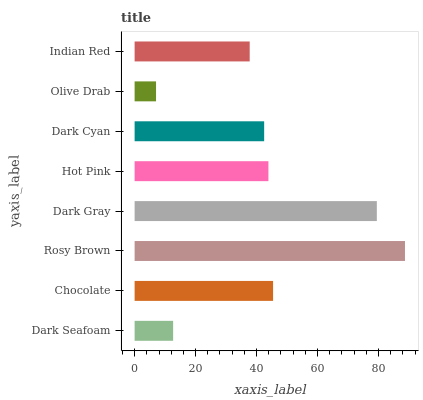Is Olive Drab the minimum?
Answer yes or no. Yes. Is Rosy Brown the maximum?
Answer yes or no. Yes. Is Chocolate the minimum?
Answer yes or no. No. Is Chocolate the maximum?
Answer yes or no. No. Is Chocolate greater than Dark Seafoam?
Answer yes or no. Yes. Is Dark Seafoam less than Chocolate?
Answer yes or no. Yes. Is Dark Seafoam greater than Chocolate?
Answer yes or no. No. Is Chocolate less than Dark Seafoam?
Answer yes or no. No. Is Hot Pink the high median?
Answer yes or no. Yes. Is Dark Cyan the low median?
Answer yes or no. Yes. Is Dark Seafoam the high median?
Answer yes or no. No. Is Hot Pink the low median?
Answer yes or no. No. 